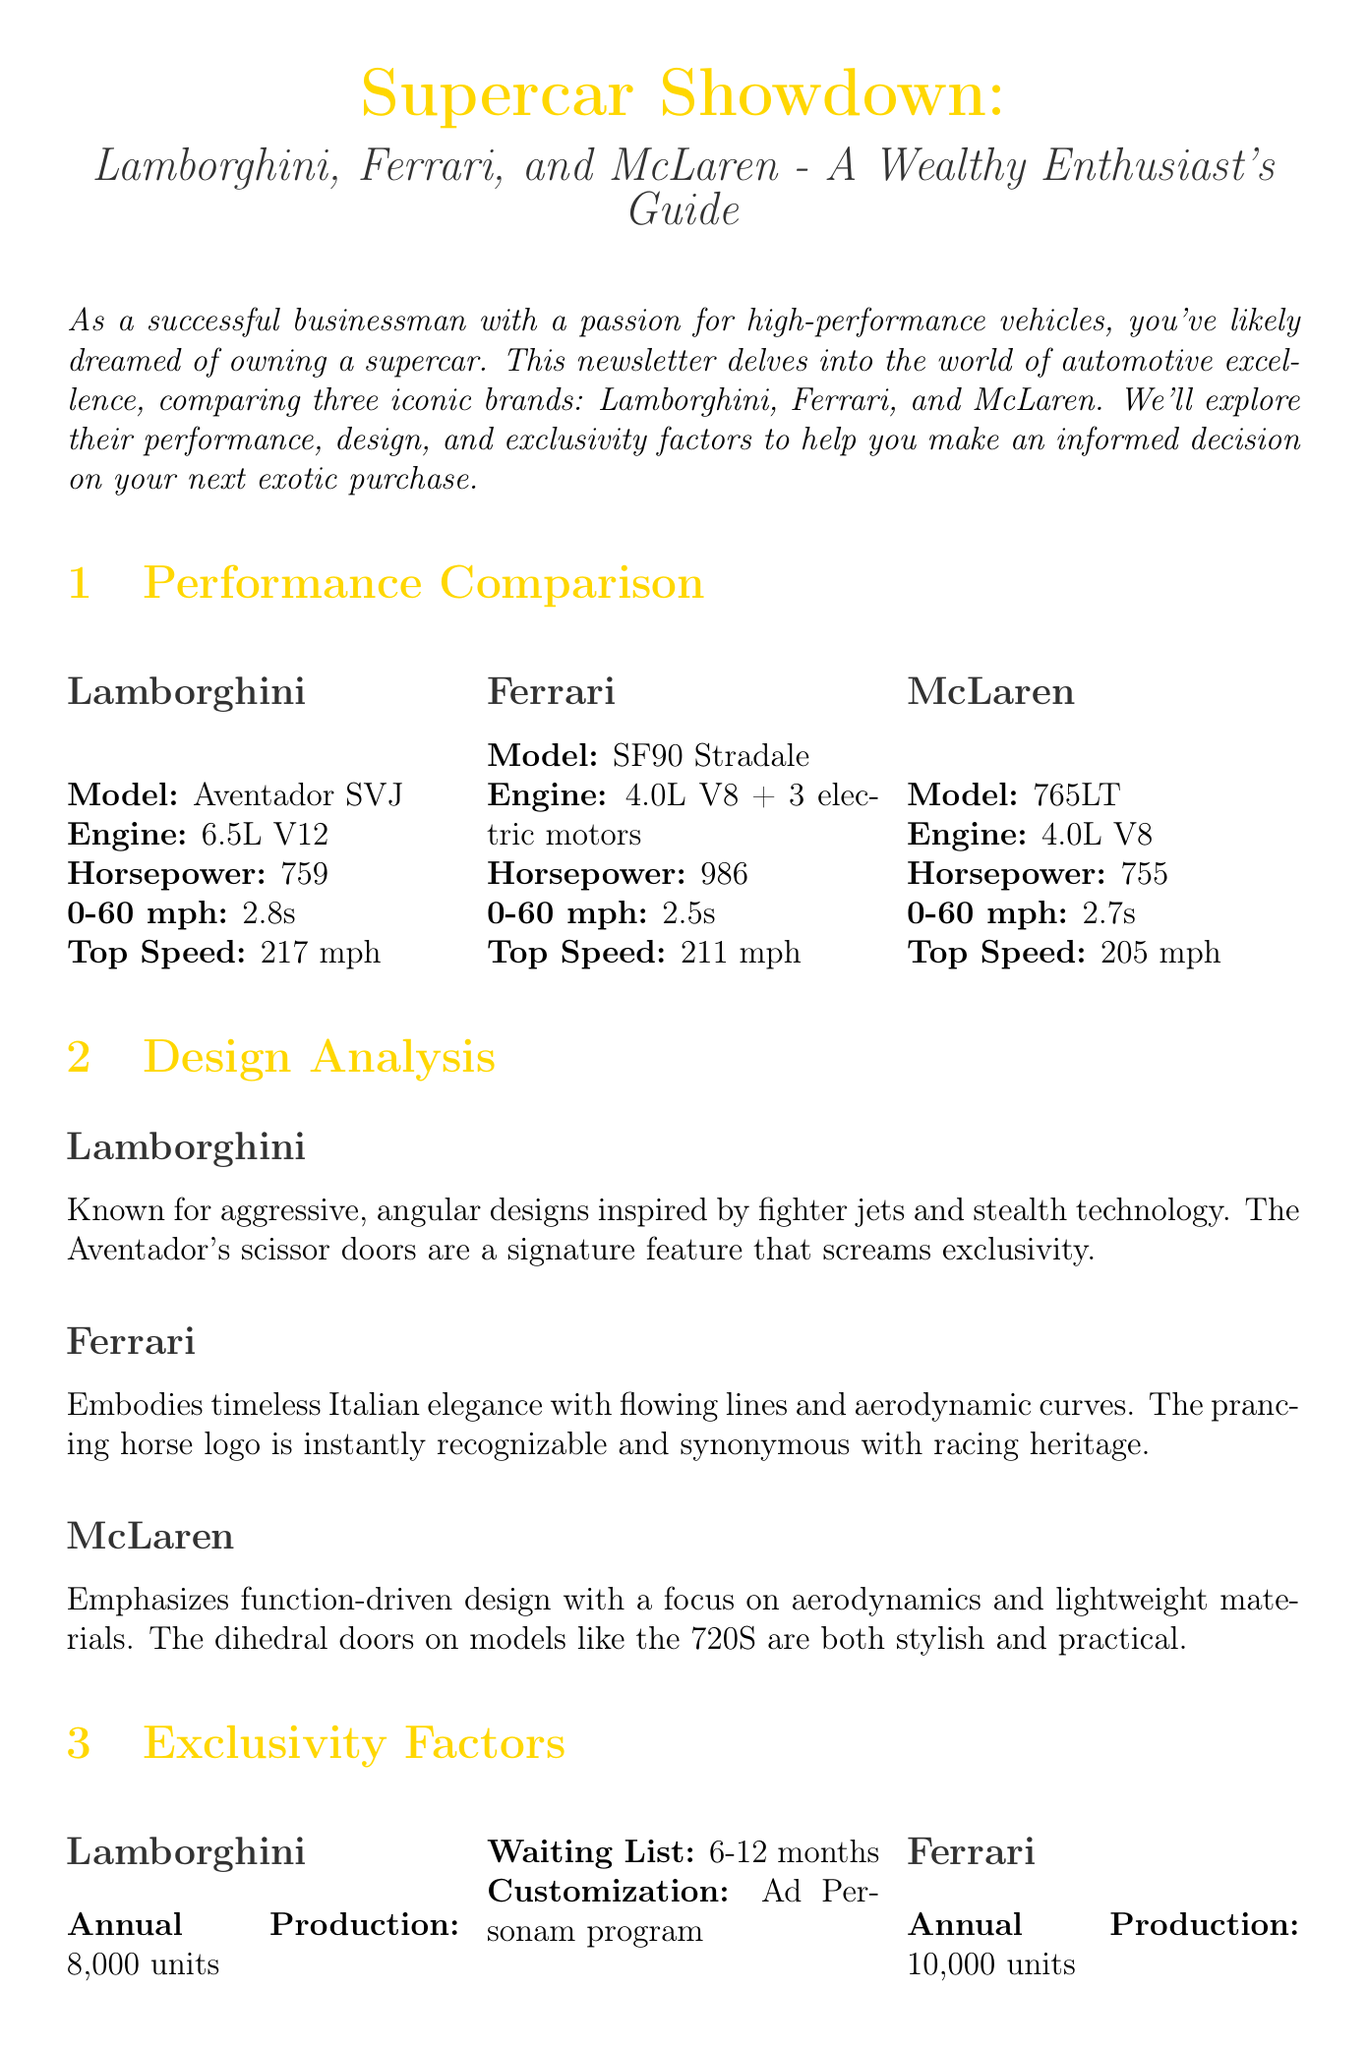What is the featured model of Lamborghini? The document provides specific featured models for each supercar brand; Lamborghini's is the Aventador SVJ.
Answer: Aventador SVJ What is the horsepower of the Ferrari SF90 Stradale? This information is presented in the performance comparison section, where each model's horsepower is listed.
Answer: 986 How long is the waiting list for McLaren models? The waiting list for McLaren is mentioned in the exclusivity factors section of the newsletter.
Answer: 3-6 months Which brand emphasizes function-driven design? The document describes the design focus of each brand, highlighting McLaren's approach.
Answer: McLaren What is the annual production of Lamborghini? Annual production figures for each brand are included in the exclusivity factors section of the newsletter.
Answer: Around 8,000 units What unique experience does the Ferrari Corse Clienti program offer? The ownership experience section explains what each program provides, specifically for Ferrari.
Answer: Formula 1 car driving experiences Which supercar has the highest 0-60 mph time? The 0-60 mph times are compared for each model, helping to determine which is the slowest.
Answer: McLaren What is the investment potential for limited edition Lamborghini models? The investment potential section evaluates specific brands and models regarding their appreciation in value.
Answer: Significant appreciation What does the McLaren Special Operations program offer? This program is listed under exclusivity factors and showcases McLaren's customization options.
Answer: Unique configurations 